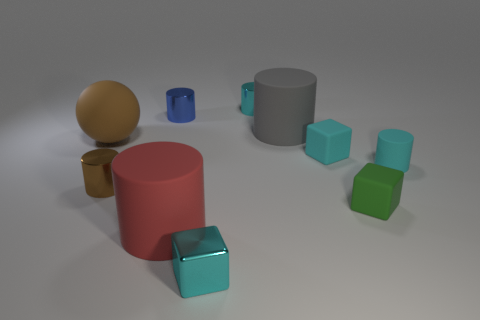Subtract all cyan cylinders. How many cylinders are left? 4 Subtract all brown cylinders. How many cylinders are left? 5 Subtract all purple cylinders. Subtract all brown cubes. How many cylinders are left? 6 Subtract all spheres. How many objects are left? 9 Subtract all big brown objects. Subtract all small cyan cubes. How many objects are left? 7 Add 9 small brown things. How many small brown things are left? 10 Add 2 big red matte cylinders. How many big red matte cylinders exist? 3 Subtract 0 gray blocks. How many objects are left? 10 